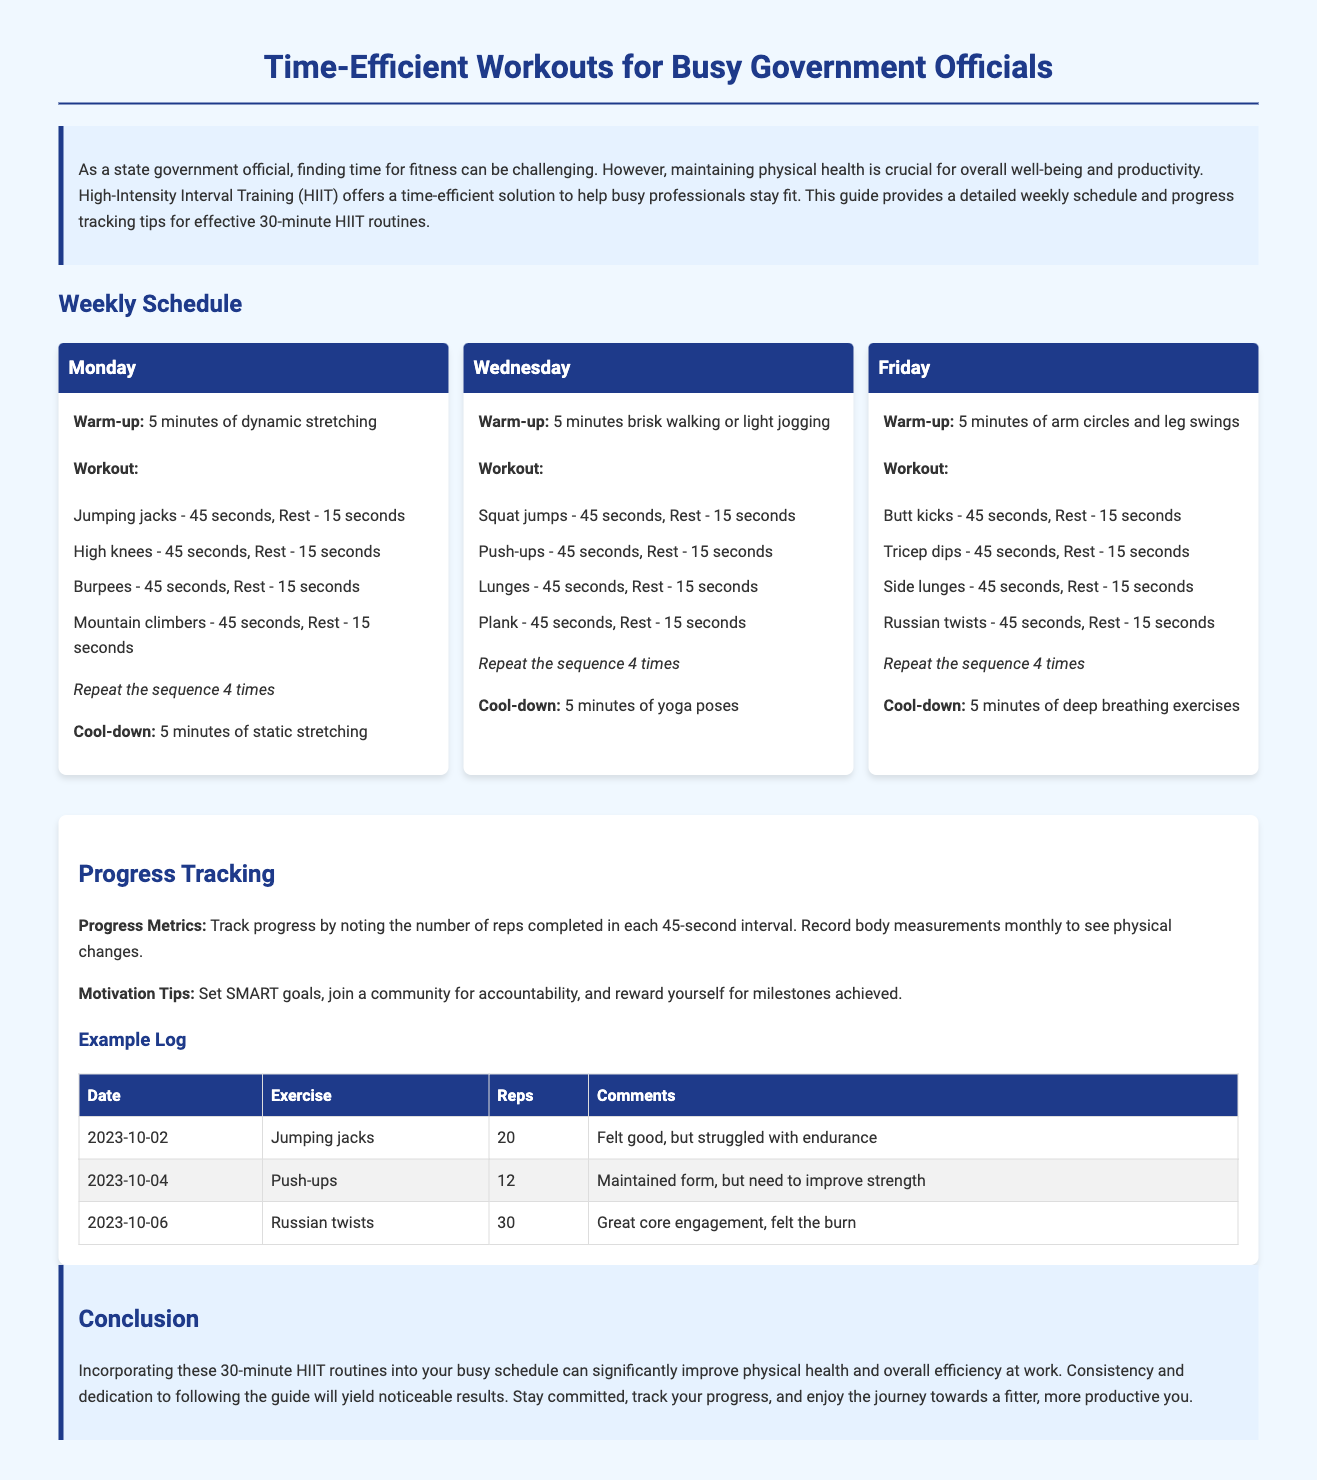What is the main focus of this workout plan? The introduction specifies that the main focus is on time-efficient workouts for busy professionals, specifically using High-Intensity Interval Training (HIIT).
Answer: Time-efficient workouts How many days per week does the workout plan suggest? The weekly schedule outlines workouts scheduled on three specific days: Monday, Wednesday, and Friday.
Answer: Three days What is the warm-up activity for Monday? The Monday section details that the warm-up consists of 5 minutes of dynamic stretching.
Answer: Dynamic stretching Which exercise is included in the Wednesday workout? The Wednesday workout section lists exercises, including squat jumps, push-ups, lunges, and plank.
Answer: Squat jumps How long should each workout sequence be repeated? The document states that the sequence of exercises should be repeated four times during the workout.
Answer: Four times What are progress metrics suggested in the tracking section? The progress tracking section mentions that participants should track the number of reps completed in each 45-second interval.
Answer: Number of reps What type of goals does the document recommend for motivation? In the progress tracking tips, the document suggests setting SMART goals.
Answer: SMART goals What is advised as a cool-down for Friday's workout? The Friday workout section indicates that the cool-down should include 5 minutes of deep breathing exercises.
Answer: Deep breathing exercises Which specific exercise had a recorded number of reps of 20 on October 2nd? The example log shows that for the date of October 2nd, the exercise logged was jumping jacks with 20 reps completed.
Answer: Jumping jacks 